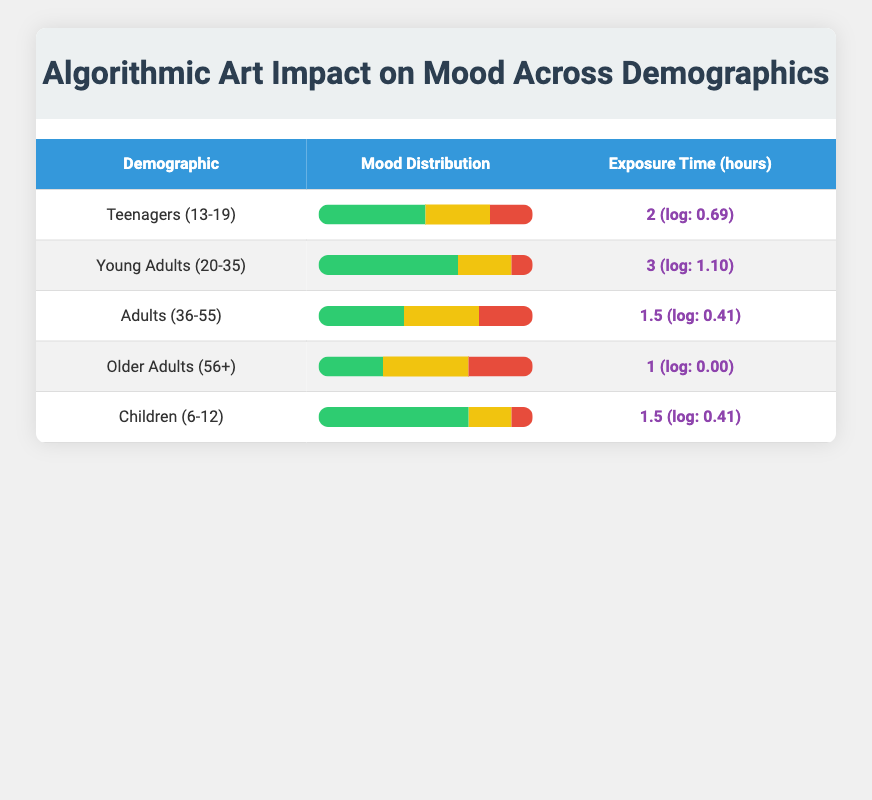What is the mood distribution for Young Adults (20-35)? For Young Adults (20-35), the mood distribution shows that 65% feel positive, 25% are neutral, and 10% feel negative. This is directly retrieved from the table.
Answer: Positive: 65%, Neutral: 25%, Negative: 10% Which demographic has the highest percentage of positivity in mood? Children (6-12) have the highest percentage of positivity at 70%. This is compared with other demographics listed in the table to find the highest value.
Answer: Children (6-12) What is the average exposure time across all demographics? The exposure times are 2, 3, 1.5, 1, and 1.5 hours, which summed gives 2 + 3 + 1.5 + 1 + 1.5 = 9. The average is then calculated as 9 / 5 = 1.8 hours.
Answer: 1.8 Is it true that Older Adults (56+) have a higher percentage of neutral mood than Adults (36-55)? Older Adults (56+) have 40% neutral mood while Adults (36-55) have 35% neutral mood; since 40% is greater than 35%, the statement is true.
Answer: Yes What is the difference in the percentage of negative mood between Teenagers (13-19) and Older Adults (56+)? Teenagers (13-19) have a negative mood percentage of 20%, while Older Adults (56+) have a negative mood percentage of 30%. The difference is calculated as 30 - 20 = 10%.
Answer: 10% 